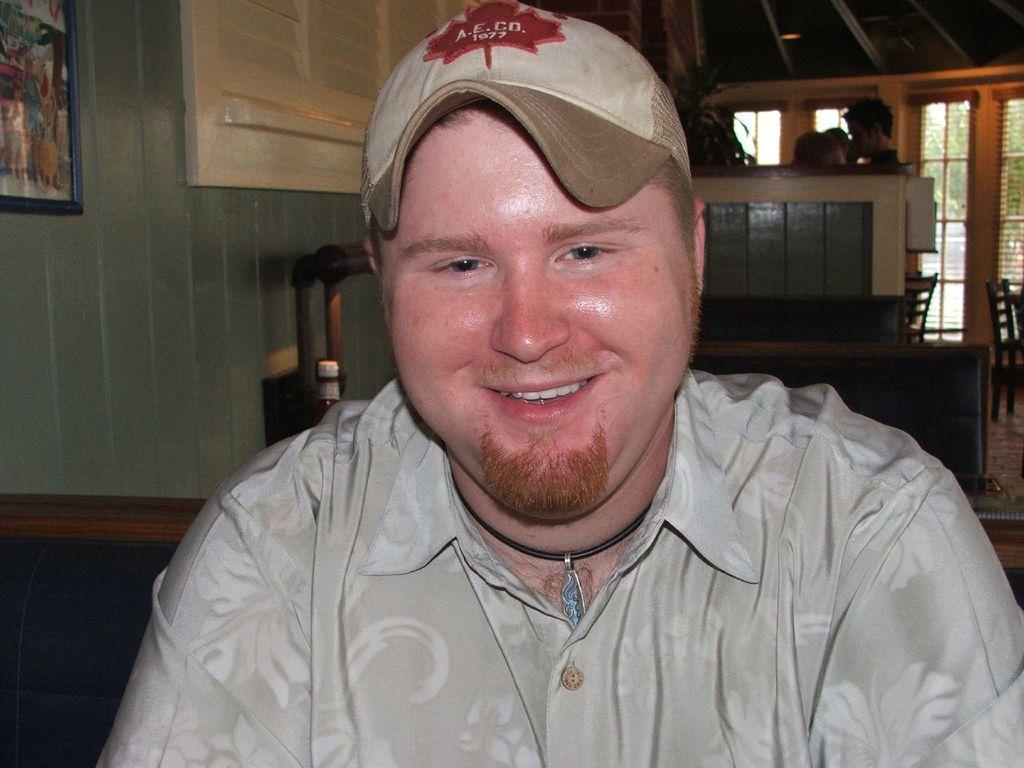Could you give a brief overview of what you see in this image? This image is taken indoors. In the background there is a wall with windows, a picture frame and grills. There are a few chairs and a table with a few things on it. In the middle of the image there is a man with a smiling face. 